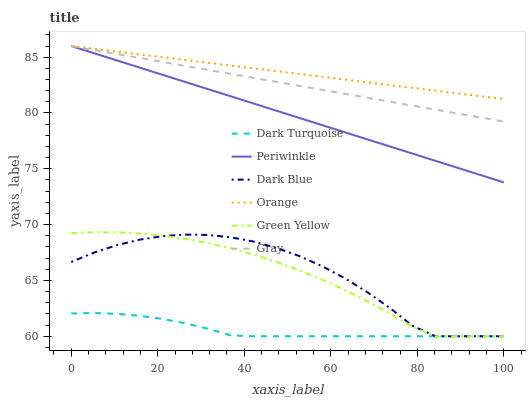Does Dark Turquoise have the minimum area under the curve?
Answer yes or no. Yes. Does Orange have the maximum area under the curve?
Answer yes or no. Yes. Does Dark Blue have the minimum area under the curve?
Answer yes or no. No. Does Dark Blue have the maximum area under the curve?
Answer yes or no. No. Is Orange the smoothest?
Answer yes or no. Yes. Is Dark Blue the roughest?
Answer yes or no. Yes. Is Dark Turquoise the smoothest?
Answer yes or no. No. Is Dark Turquoise the roughest?
Answer yes or no. No. Does Periwinkle have the lowest value?
Answer yes or no. No. Does Orange have the highest value?
Answer yes or no. Yes. Does Dark Blue have the highest value?
Answer yes or no. No. Is Dark Turquoise less than Periwinkle?
Answer yes or no. Yes. Is Periwinkle greater than Dark Blue?
Answer yes or no. Yes. Does Orange intersect Periwinkle?
Answer yes or no. Yes. Is Orange less than Periwinkle?
Answer yes or no. No. Is Orange greater than Periwinkle?
Answer yes or no. No. Does Dark Turquoise intersect Periwinkle?
Answer yes or no. No. 